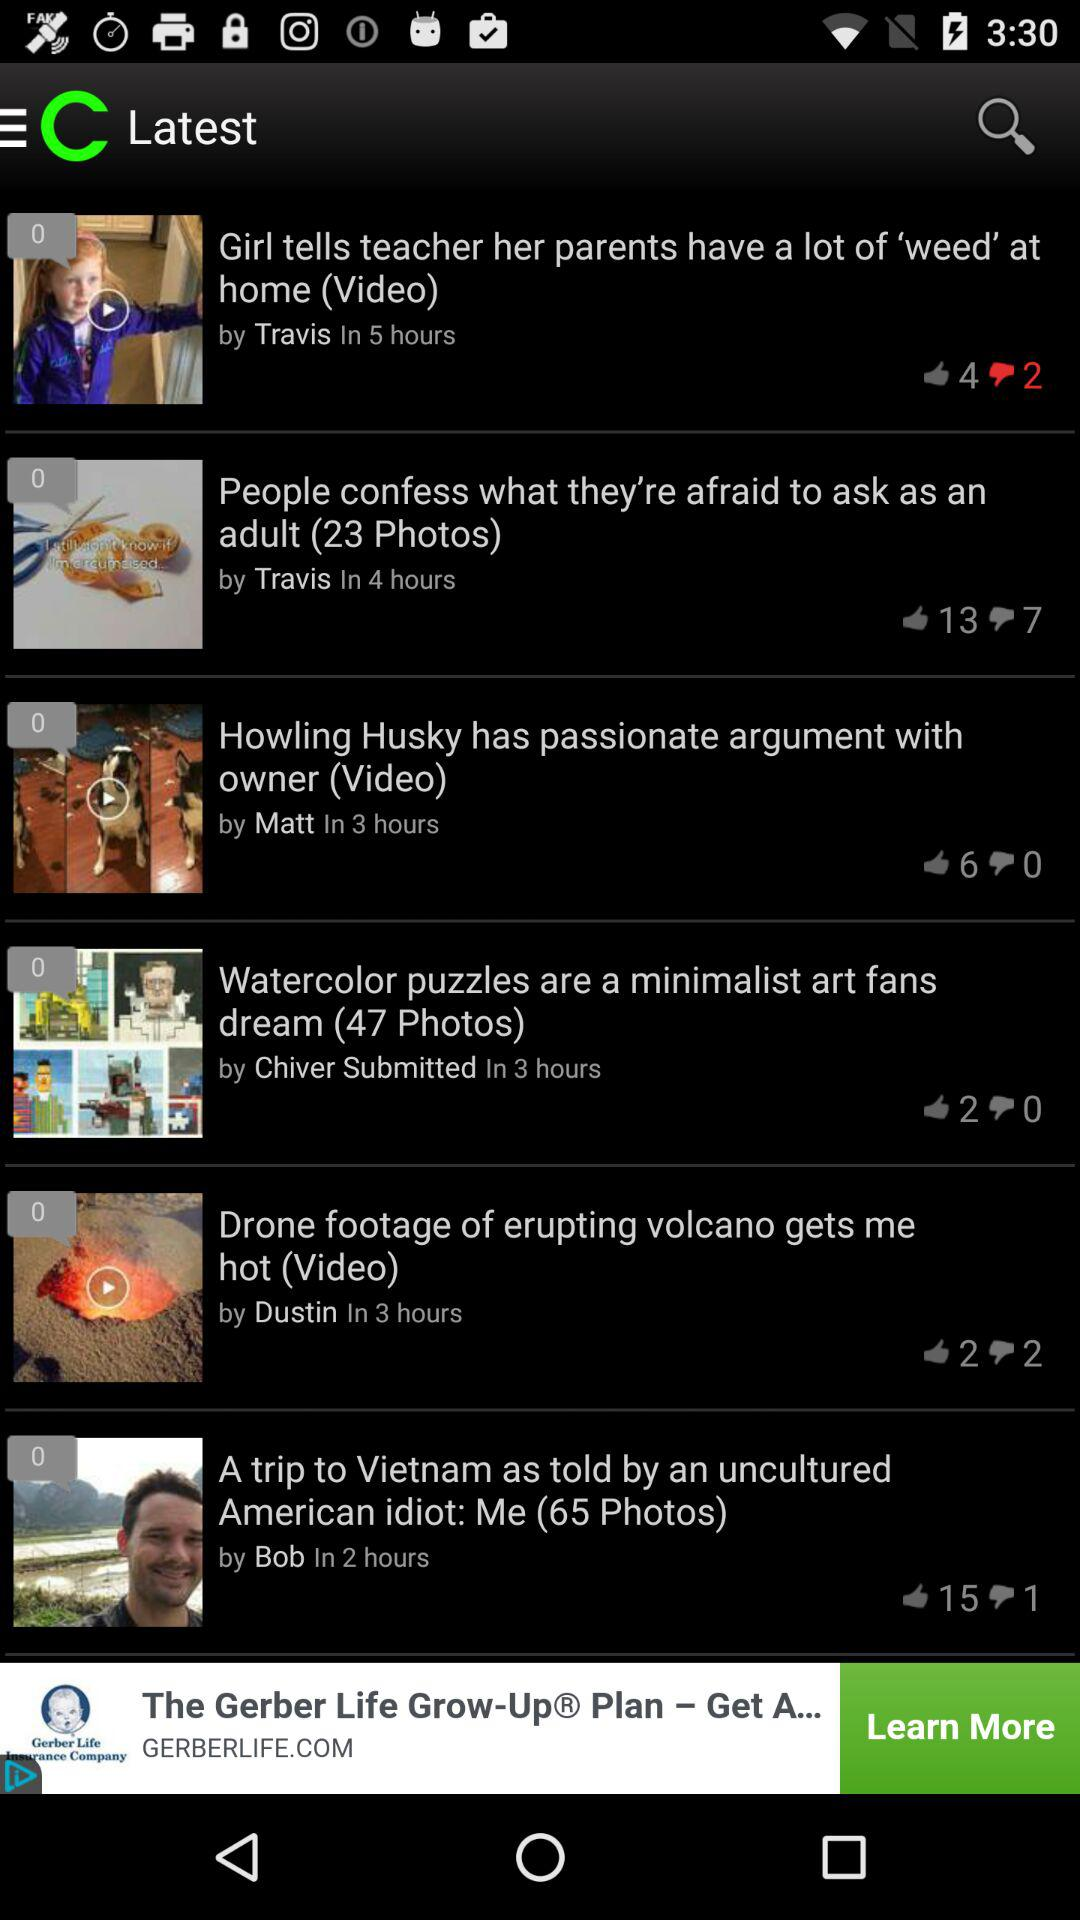Who posted "A trip to Vietnam as told by an uncultured American idiot"? "A trip to Vietnam as told by an uncultured American idiot" was posted by Bob. 